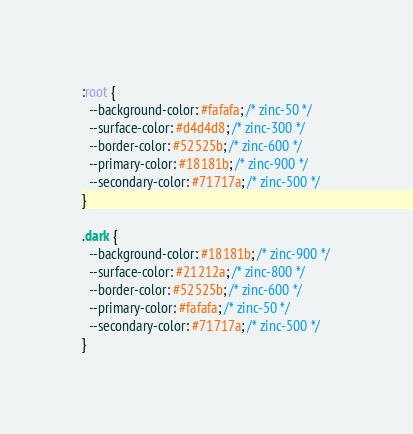Convert code to text. <code><loc_0><loc_0><loc_500><loc_500><_CSS_>:root {
  --background-color: #fafafa; /* zinc-50 */
  --surface-color: #d4d4d8; /* zinc-300 */
  --border-color: #52525b; /* zinc-600 */
  --primary-color: #18181b; /* zinc-900 */
  --secondary-color: #71717a; /* zinc-500 */
}

.dark {
  --background-color: #18181b; /* zinc-900 */
  --surface-color: #21212a; /* zinc-800 */
  --border-color: #52525b; /* zinc-600 */
  --primary-color: #fafafa; /* zinc-50 */
  --secondary-color: #71717a; /* zinc-500 */
}
</code> 